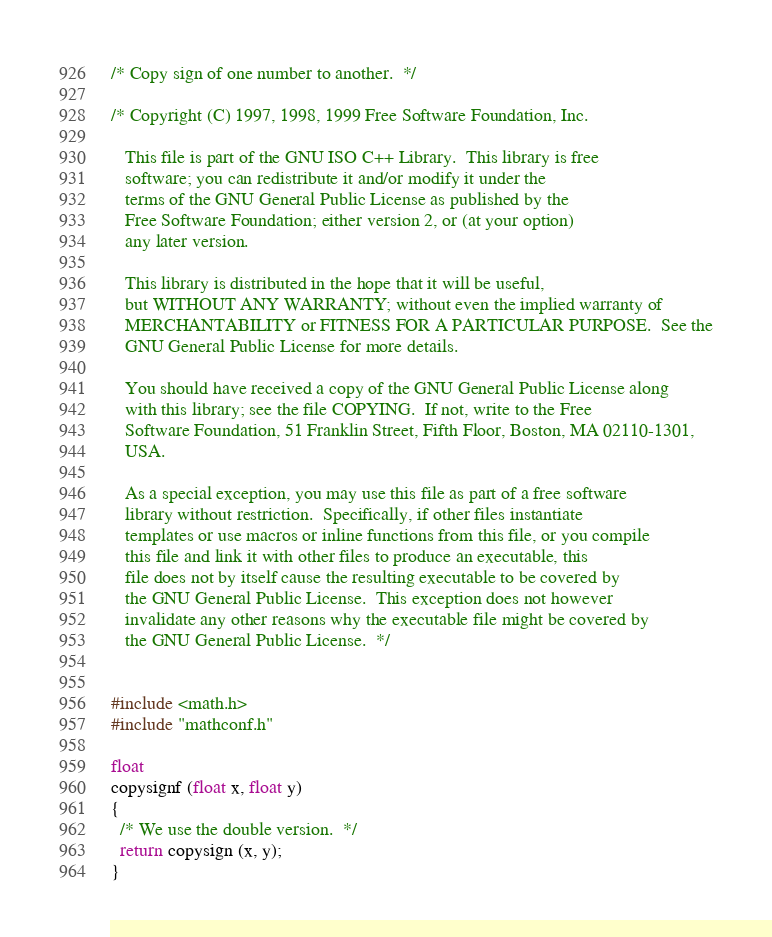<code> <loc_0><loc_0><loc_500><loc_500><_C_>/* Copy sign of one number to another.  */

/* Copyright (C) 1997, 1998, 1999 Free Software Foundation, Inc.

   This file is part of the GNU ISO C++ Library.  This library is free
   software; you can redistribute it and/or modify it under the
   terms of the GNU General Public License as published by the
   Free Software Foundation; either version 2, or (at your option)
   any later version.

   This library is distributed in the hope that it will be useful,
   but WITHOUT ANY WARRANTY; without even the implied warranty of
   MERCHANTABILITY or FITNESS FOR A PARTICULAR PURPOSE.  See the
   GNU General Public License for more details.

   You should have received a copy of the GNU General Public License along
   with this library; see the file COPYING.  If not, write to the Free
   Software Foundation, 51 Franklin Street, Fifth Floor, Boston, MA 02110-1301,
   USA.

   As a special exception, you may use this file as part of a free software
   library without restriction.  Specifically, if other files instantiate
   templates or use macros or inline functions from this file, or you compile
   this file and link it with other files to produce an executable, this
   file does not by itself cause the resulting executable to be covered by
   the GNU General Public License.  This exception does not however
   invalidate any other reasons why the executable file might be covered by
   the GNU General Public License.  */


#include <math.h>
#include "mathconf.h"

float
copysignf (float x, float y)
{
  /* We use the double version.  */
  return copysign (x, y);
}
</code> 